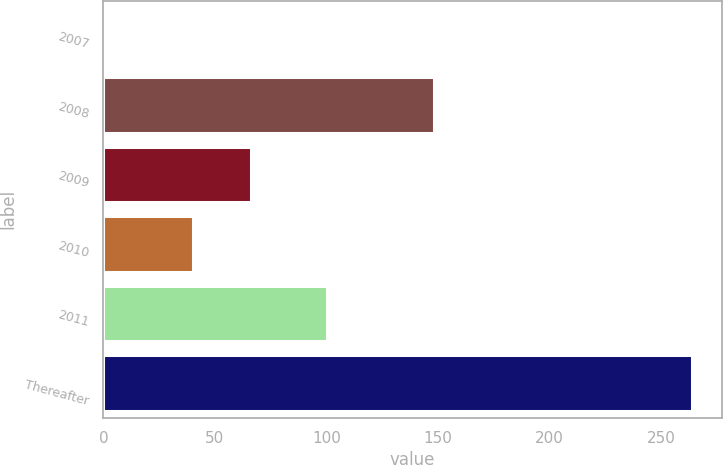Convert chart to OTSL. <chart><loc_0><loc_0><loc_500><loc_500><bar_chart><fcel>2007<fcel>2008<fcel>2009<fcel>2010<fcel>2011<fcel>Thereafter<nl><fcel>1<fcel>148<fcel>66.3<fcel>40<fcel>100<fcel>264<nl></chart> 